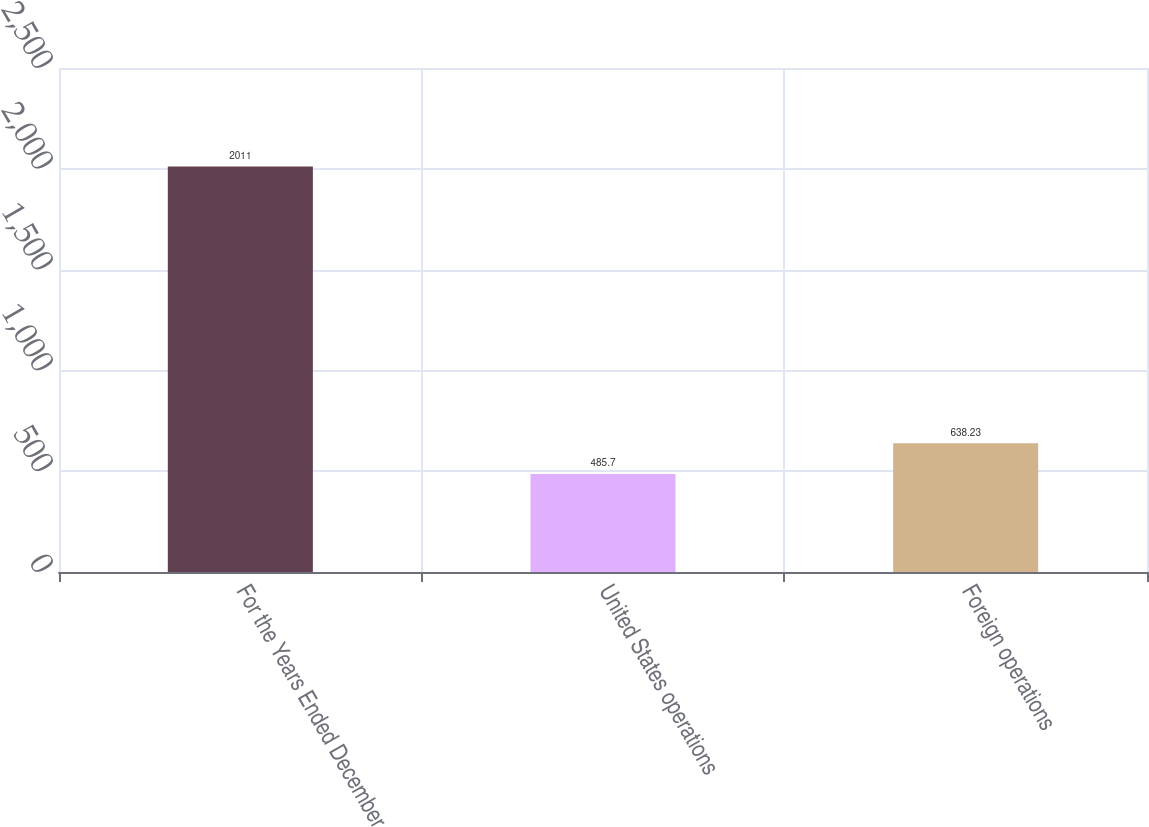Convert chart to OTSL. <chart><loc_0><loc_0><loc_500><loc_500><bar_chart><fcel>For the Years Ended December<fcel>United States operations<fcel>Foreign operations<nl><fcel>2011<fcel>485.7<fcel>638.23<nl></chart> 